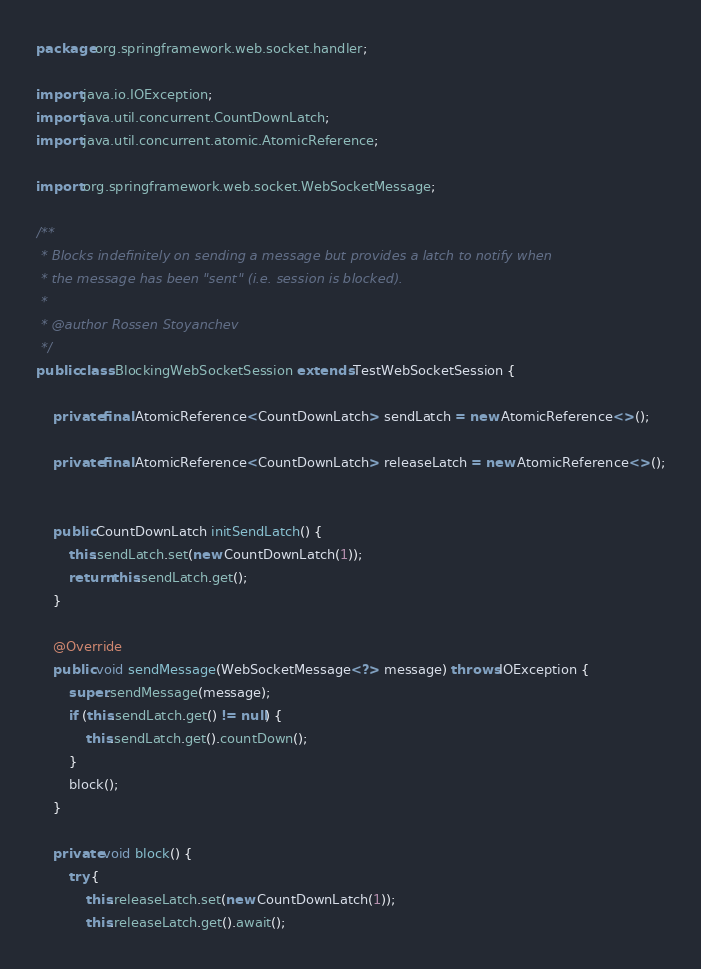<code> <loc_0><loc_0><loc_500><loc_500><_Java_>
package org.springframework.web.socket.handler;

import java.io.IOException;
import java.util.concurrent.CountDownLatch;
import java.util.concurrent.atomic.AtomicReference;

import org.springframework.web.socket.WebSocketMessage;

/**
 * Blocks indefinitely on sending a message but provides a latch to notify when
 * the message has been "sent" (i.e. session is blocked).
 *
 * @author Rossen Stoyanchev
 */
public class BlockingWebSocketSession extends TestWebSocketSession {

	private final AtomicReference<CountDownLatch> sendLatch = new AtomicReference<>();

	private final AtomicReference<CountDownLatch> releaseLatch = new AtomicReference<>();


	public CountDownLatch initSendLatch() {
		this.sendLatch.set(new CountDownLatch(1));
		return this.sendLatch.get();
	}

	@Override
	public void sendMessage(WebSocketMessage<?> message) throws IOException {
		super.sendMessage(message);
		if (this.sendLatch.get() != null) {
			this.sendLatch.get().countDown();
		}
		block();
	}

	private void block() {
		try {
			this.releaseLatch.set(new CountDownLatch(1));
			this.releaseLatch.get().await();</code> 